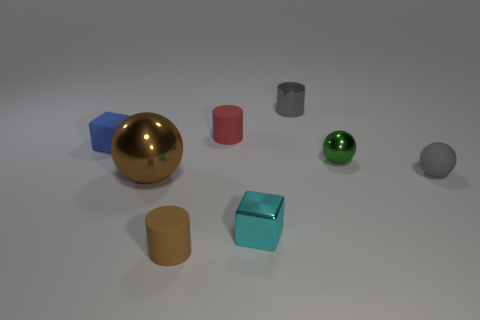Add 1 small blue matte things. How many objects exist? 9 Subtract all cubes. How many objects are left? 6 Add 4 brown objects. How many brown objects exist? 6 Subtract 0 red balls. How many objects are left? 8 Subtract all blue matte cubes. Subtract all big brown metal spheres. How many objects are left? 6 Add 2 large brown spheres. How many large brown spheres are left? 3 